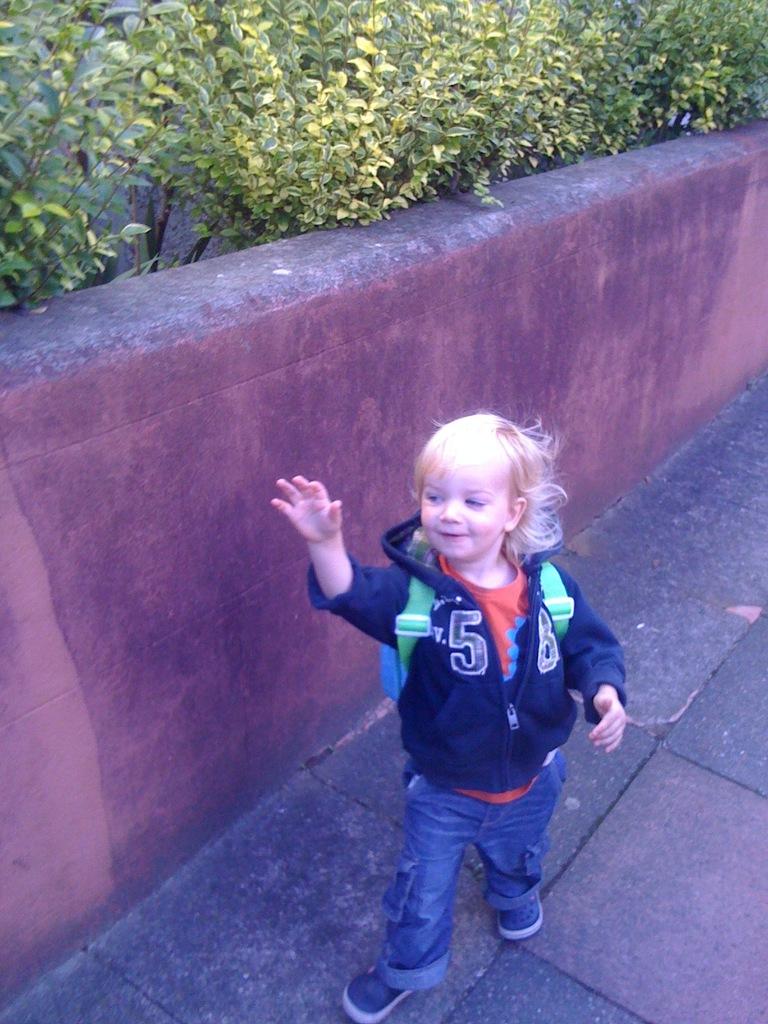What is the left number on the hoodie?
Your response must be concise. 5. 